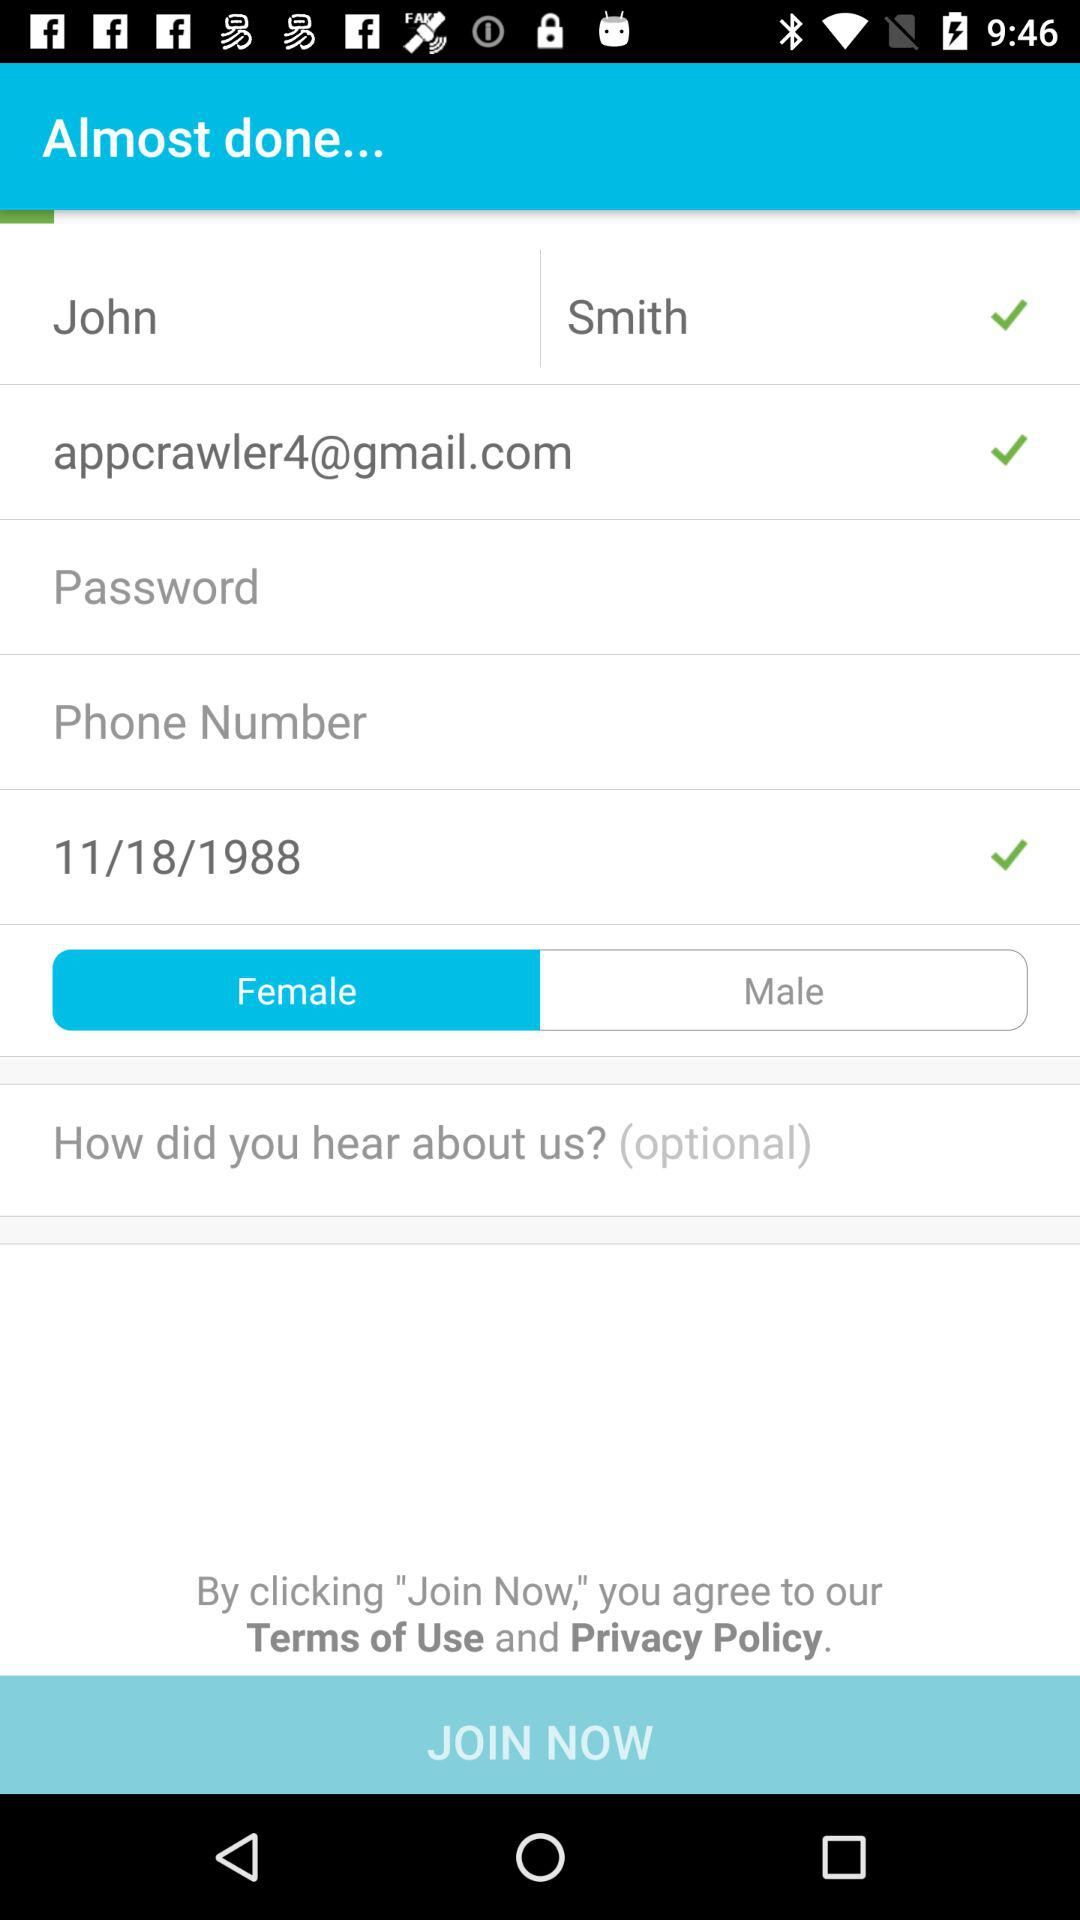How many text inputs have a checkmark next to them?
Answer the question using a single word or phrase. 3 